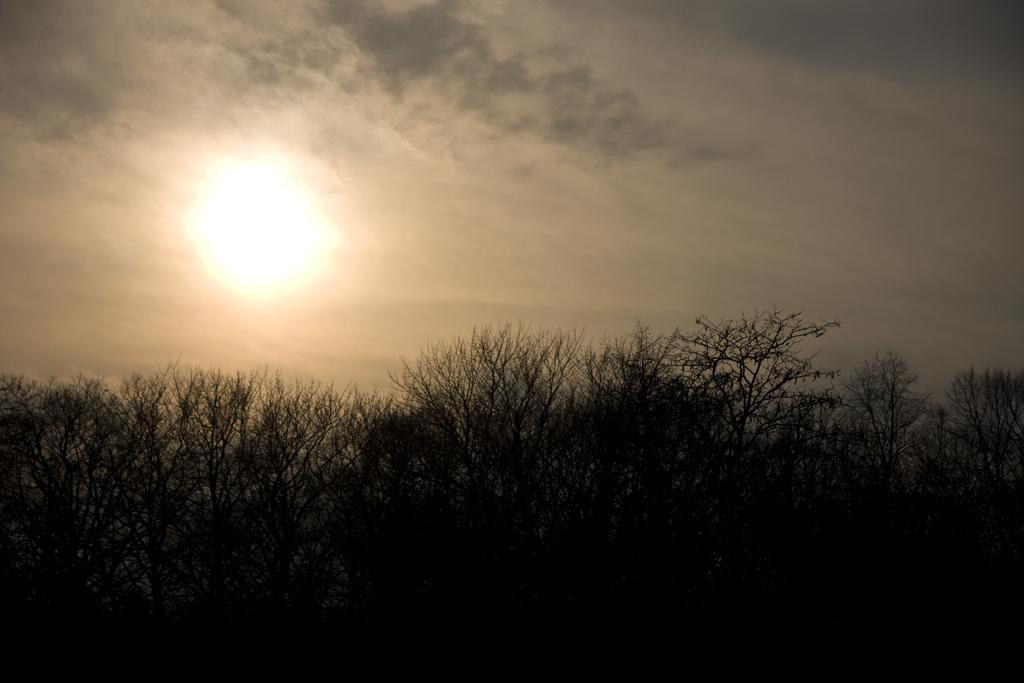Can you describe this image briefly? This image is taken outdoors. At the bottom of the image there a few trees and plants. At the top of the image there is a sky with clouds and sun. 